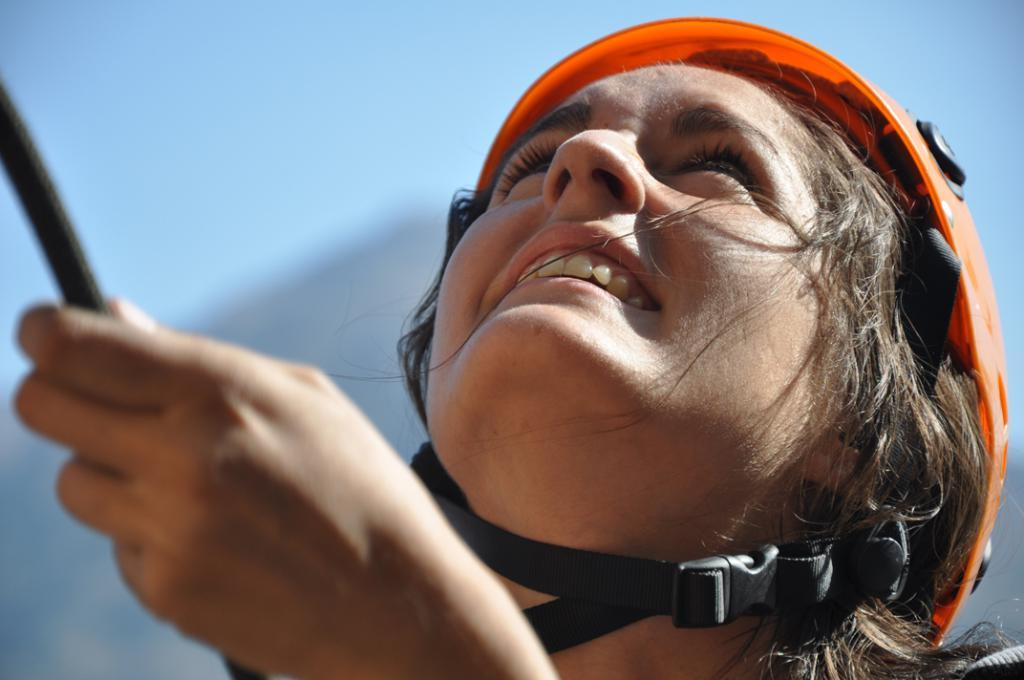What is the main subject of the image? There is a person in the image. What is the person's facial expression? The person is smiling. What is the person holding in the image? The person is holding an object that is black in color. Can you describe the background of the image? The background of the image is blurry. What type of punishment is being administered to the person in the image? There is no indication of punishment in the image; the person is smiling and holding a black object. What order is the person following in the image? There is no indication of an order being followed in the image; the person is simply holding a black object and smiling. 